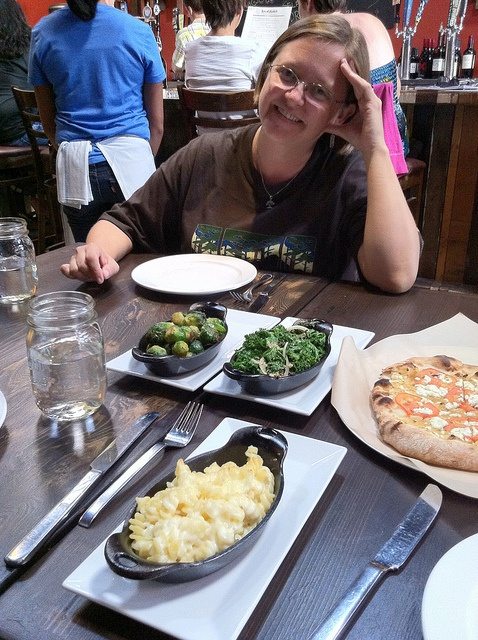Describe the objects in this image and their specific colors. I can see dining table in black, lightgray, gray, and darkgray tones, people in black, brown, maroon, and gray tones, people in black, blue, navy, and lightblue tones, bowl in black, khaki, beige, and gray tones, and pizza in black, tan, and beige tones in this image. 